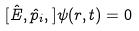<formula> <loc_0><loc_0><loc_500><loc_500>[ \hat { E } , \hat { p } _ { i } , ] \psi ( r , t ) = 0</formula> 